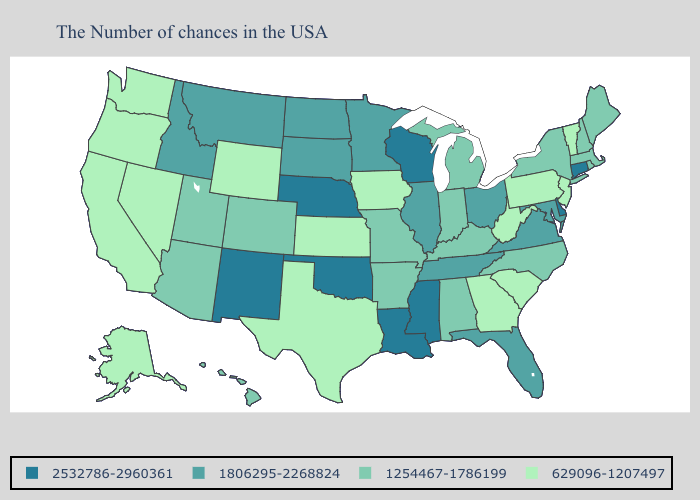Does the first symbol in the legend represent the smallest category?
Give a very brief answer. No. What is the highest value in states that border Michigan?
Write a very short answer. 2532786-2960361. Does Texas have the same value as Alabama?
Keep it brief. No. Name the states that have a value in the range 1254467-1786199?
Quick response, please. Maine, Massachusetts, Rhode Island, New Hampshire, New York, North Carolina, Michigan, Kentucky, Indiana, Alabama, Missouri, Arkansas, Colorado, Utah, Arizona, Hawaii. Name the states that have a value in the range 2532786-2960361?
Give a very brief answer. Connecticut, Delaware, Wisconsin, Mississippi, Louisiana, Nebraska, Oklahoma, New Mexico. Does Connecticut have the lowest value in the USA?
Quick response, please. No. What is the value of Mississippi?
Quick response, please. 2532786-2960361. What is the highest value in the West ?
Answer briefly. 2532786-2960361. Does Washington have the lowest value in the West?
Be succinct. Yes. What is the value of Minnesota?
Be succinct. 1806295-2268824. Does California have the lowest value in the West?
Keep it brief. Yes. What is the value of Ohio?
Short answer required. 1806295-2268824. What is the value of Virginia?
Write a very short answer. 1806295-2268824. Does Arizona have the lowest value in the West?
Short answer required. No. What is the value of Massachusetts?
Concise answer only. 1254467-1786199. 